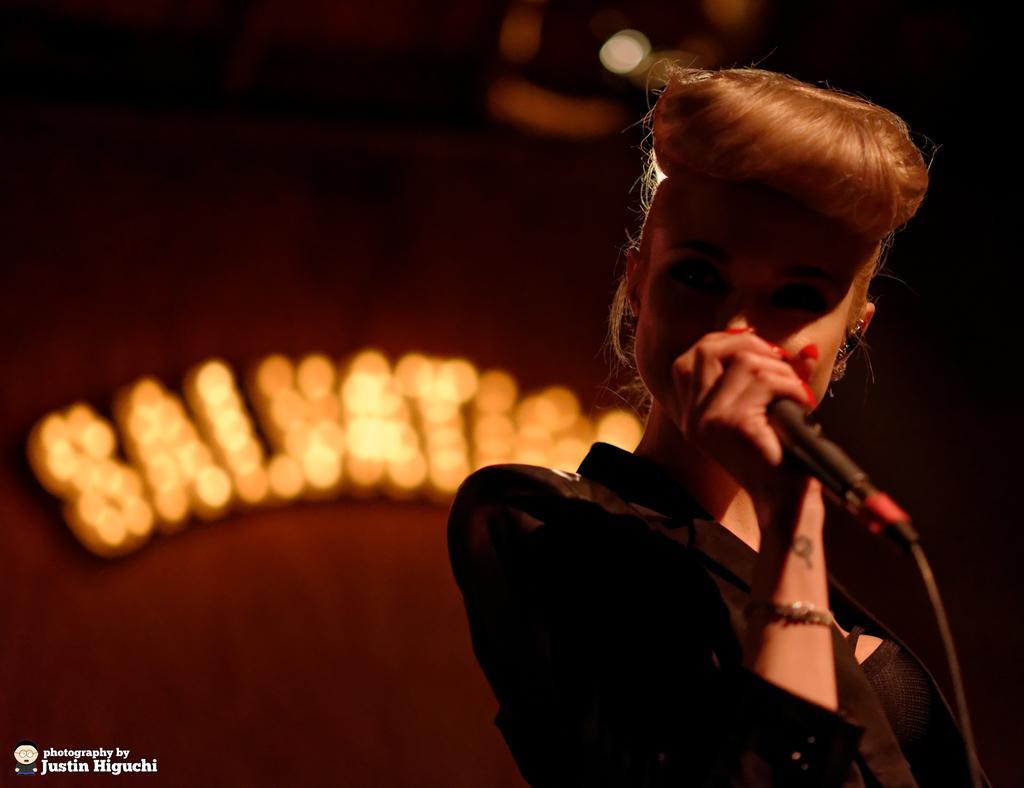In one or two sentences, can you explain what this image depicts? In this image we can see a woman holding a mic. On the backside we can see some text on a wall with some lights. 